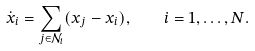Convert formula to latex. <formula><loc_0><loc_0><loc_500><loc_500>\dot { x } _ { i } = \sum _ { j \in \mathcal { N } _ { i } } ( x _ { j } - x _ { i } ) , \quad i = 1 , \dots , N .</formula> 